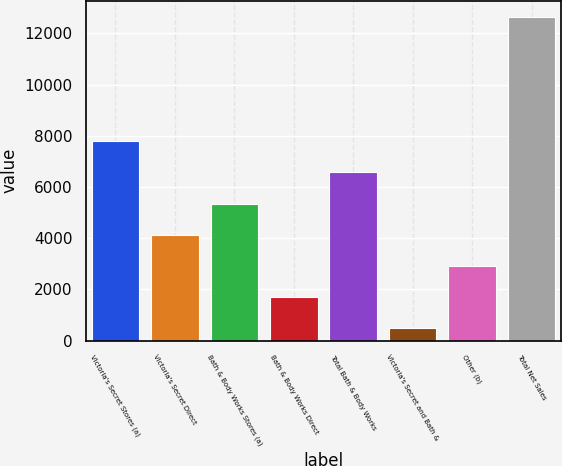Convert chart. <chart><loc_0><loc_0><loc_500><loc_500><bar_chart><fcel>Victoria's Secret Stores (a)<fcel>Victoria's Secret Direct<fcel>Bath & Body Works Stores (a)<fcel>Bath & Body Works Direct<fcel>Total Bath & Body Works<fcel>Victoria's Secret and Bath &<fcel>Other (b)<fcel>Total Net Sales<nl><fcel>7780<fcel>4141<fcel>5354<fcel>1715<fcel>6567<fcel>502<fcel>2928<fcel>12632<nl></chart> 